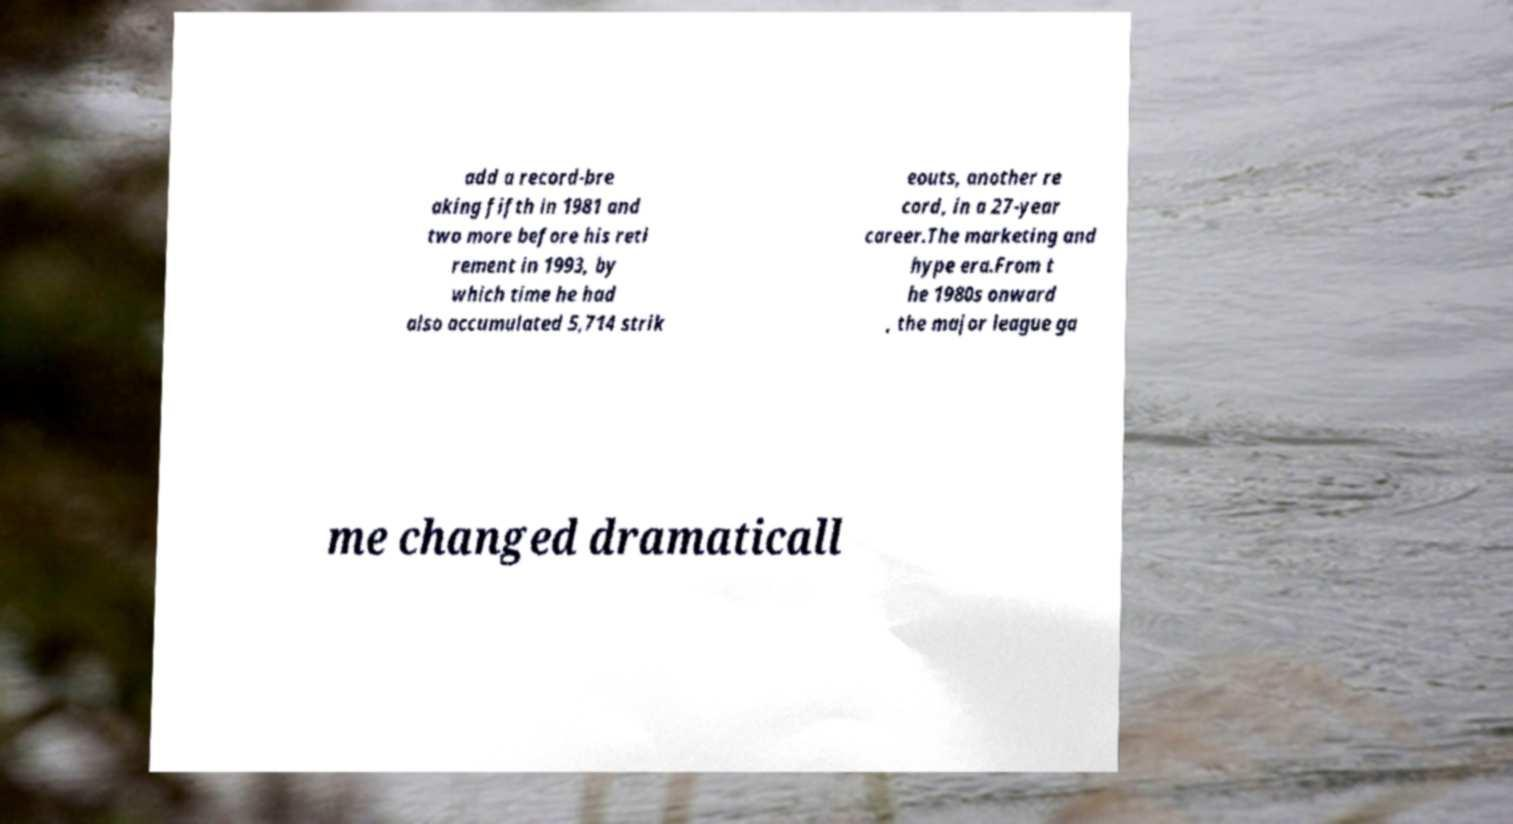What messages or text are displayed in this image? I need them in a readable, typed format. add a record-bre aking fifth in 1981 and two more before his reti rement in 1993, by which time he had also accumulated 5,714 strik eouts, another re cord, in a 27-year career.The marketing and hype era.From t he 1980s onward , the major league ga me changed dramaticall 